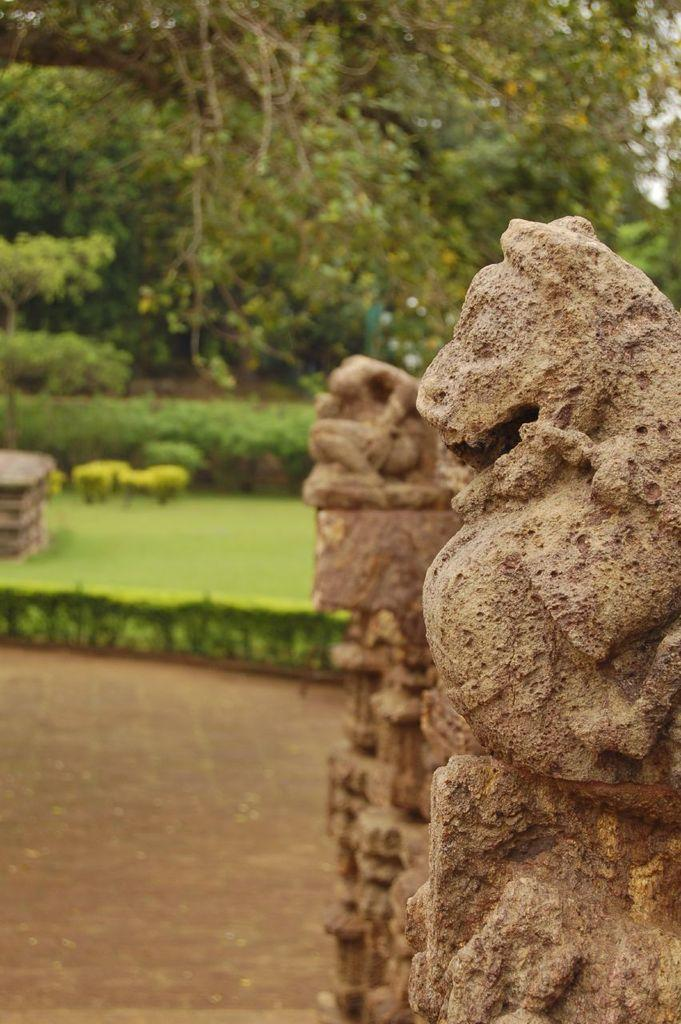What type of material is used to create the sculptures in the image? The sculptures in the image are made of stones. What type of vegetation can be seen in the image? There is grass, plants, and trees visible in the image. What type of flame can be seen coming from the sculptures in the image? There is no flame present in the image; the sculptures are made of stones and do not emit any flames. 